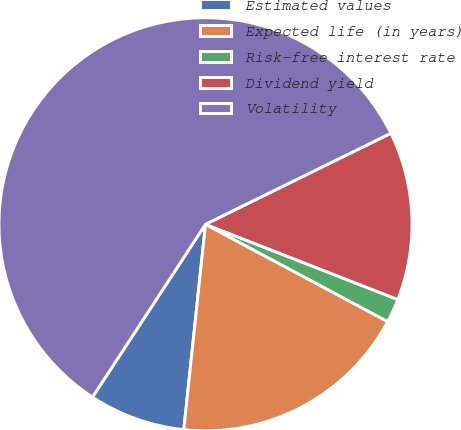<chart> <loc_0><loc_0><loc_500><loc_500><pie_chart><fcel>Estimated values<fcel>Expected life (in years)<fcel>Risk-free interest rate<fcel>Dividend yield<fcel>Volatility<nl><fcel>7.54%<fcel>18.87%<fcel>1.87%<fcel>13.2%<fcel>58.52%<nl></chart> 